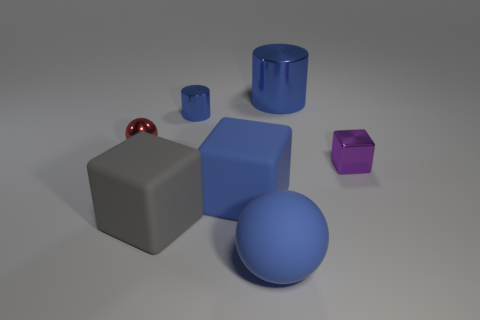Subtract all large cubes. How many cubes are left? 1 Add 2 big red matte cylinders. How many objects exist? 9 Subtract all cylinders. How many objects are left? 5 Subtract 1 spheres. How many spheres are left? 1 Subtract all small brown metallic cylinders. Subtract all blue cubes. How many objects are left? 6 Add 1 large blue rubber spheres. How many large blue rubber spheres are left? 2 Add 5 cyan metal balls. How many cyan metal balls exist? 5 Subtract 2 blue cylinders. How many objects are left? 5 Subtract all yellow cylinders. Subtract all cyan balls. How many cylinders are left? 2 